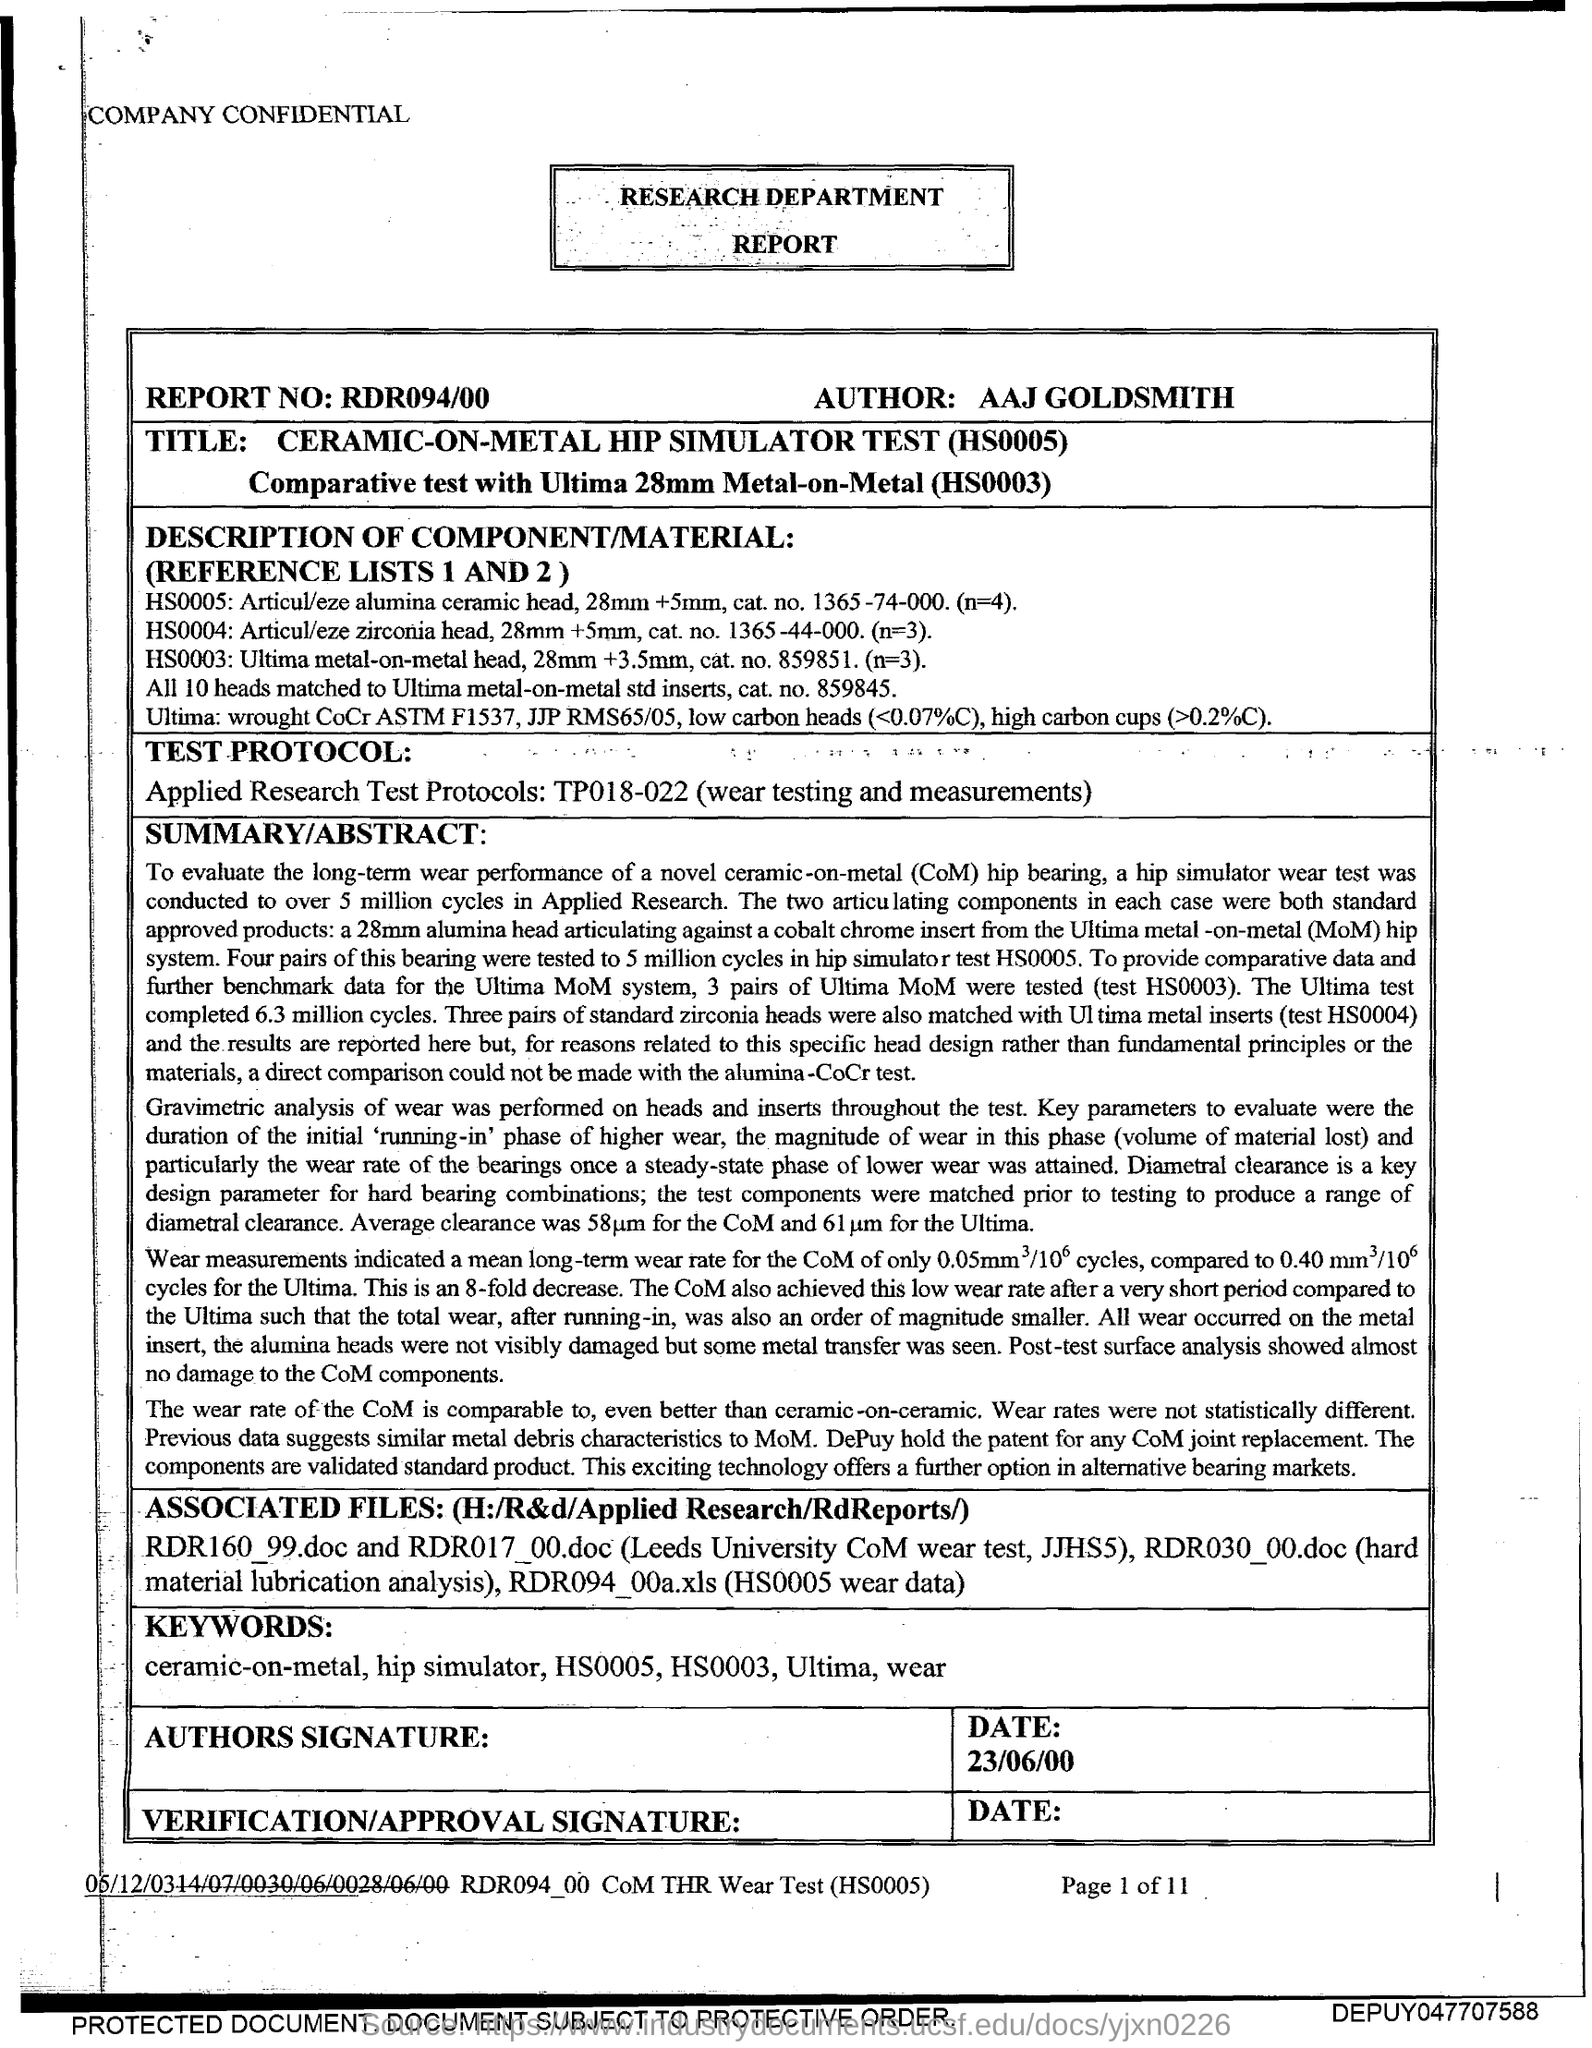What is the date mentioned in this report?
Your answer should be compact. 23/06/00. What is the report number mentioned?
Offer a terse response. RDR094/00. 